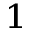<formula> <loc_0><loc_0><loc_500><loc_500>^ { 1 }</formula> 